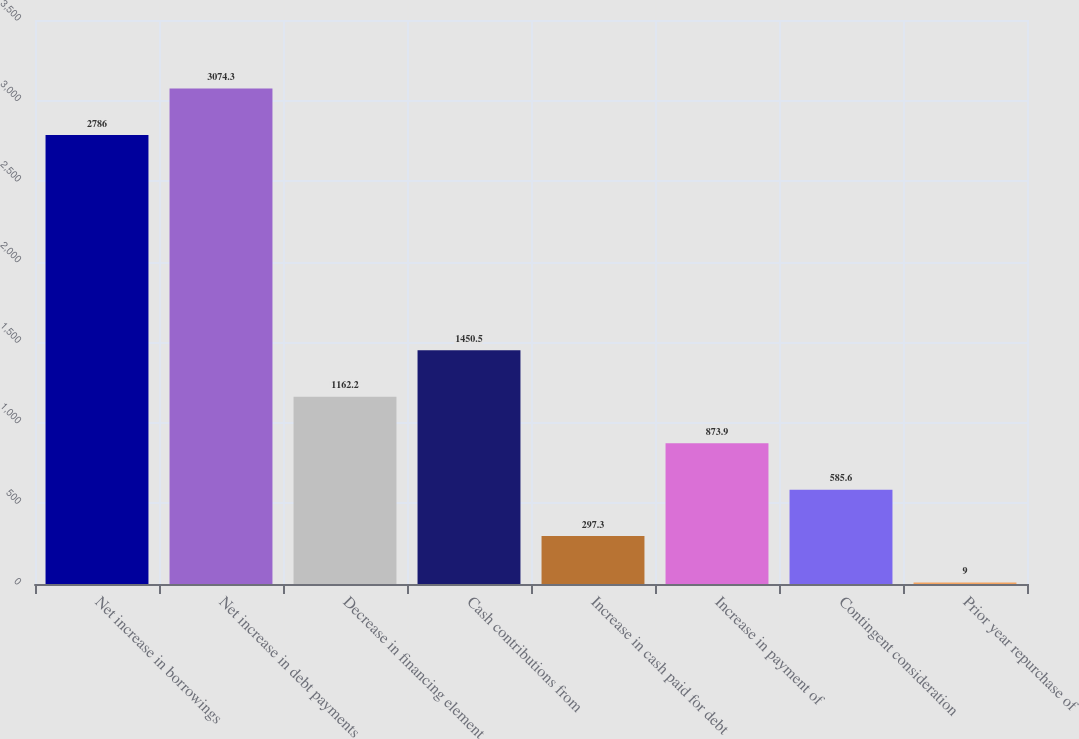<chart> <loc_0><loc_0><loc_500><loc_500><bar_chart><fcel>Net increase in borrowings<fcel>Net increase in debt payments<fcel>Decrease in financing element<fcel>Cash contributions from<fcel>Increase in cash paid for debt<fcel>Increase in payment of<fcel>Contingent consideration<fcel>Prior year repurchase of<nl><fcel>2786<fcel>3074.3<fcel>1162.2<fcel>1450.5<fcel>297.3<fcel>873.9<fcel>585.6<fcel>9<nl></chart> 